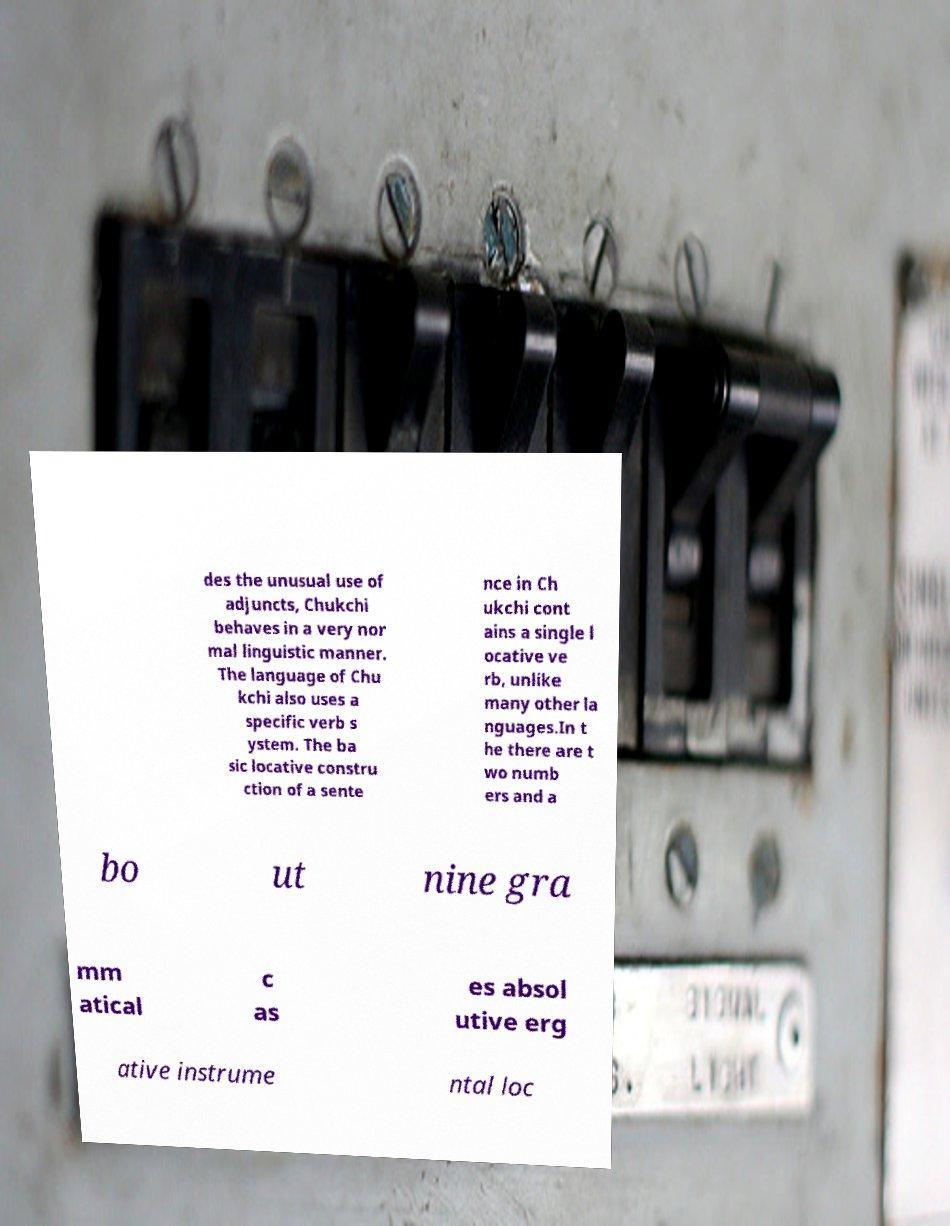Could you assist in decoding the text presented in this image and type it out clearly? des the unusual use of adjuncts, Chukchi behaves in a very nor mal linguistic manner. The language of Chu kchi also uses a specific verb s ystem. The ba sic locative constru ction of a sente nce in Ch ukchi cont ains a single l ocative ve rb, unlike many other la nguages.In t he there are t wo numb ers and a bo ut nine gra mm atical c as es absol utive erg ative instrume ntal loc 